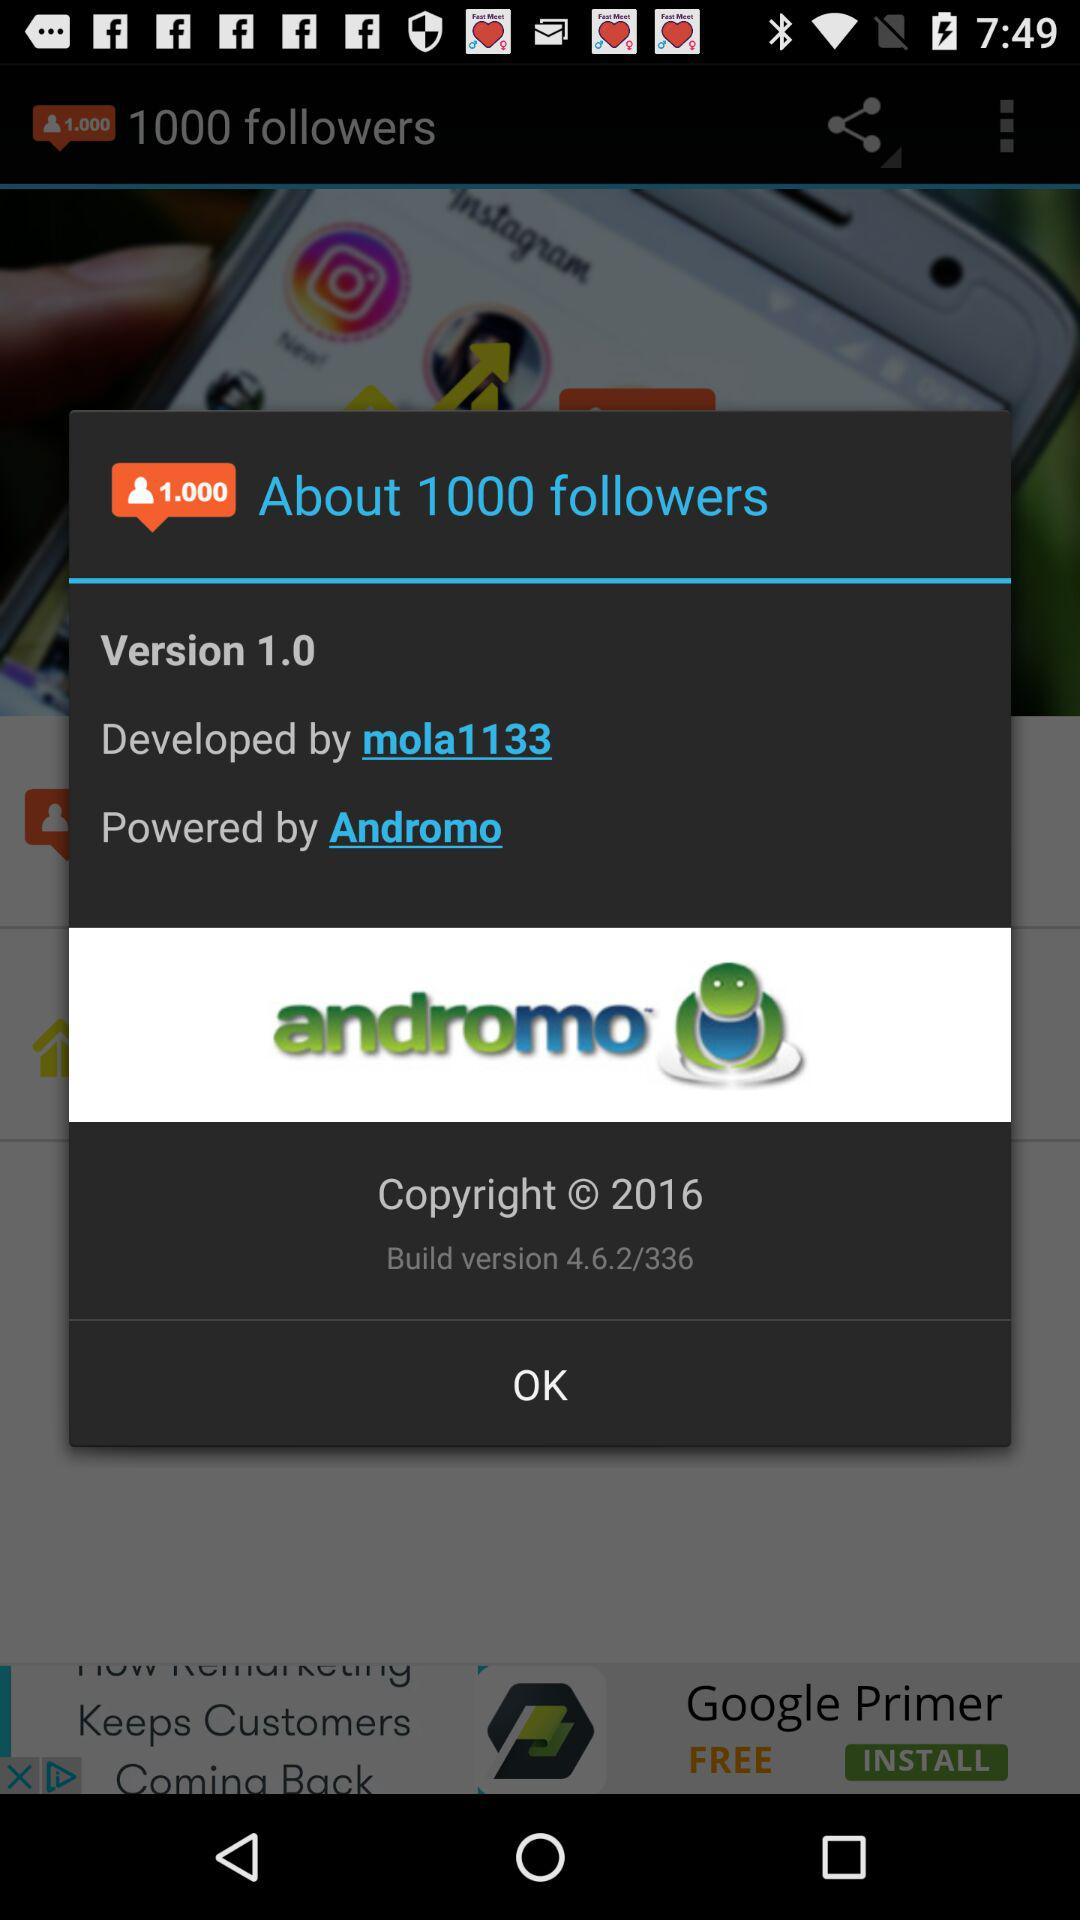What is the build version of application? The build version is 4.6.2/336. 